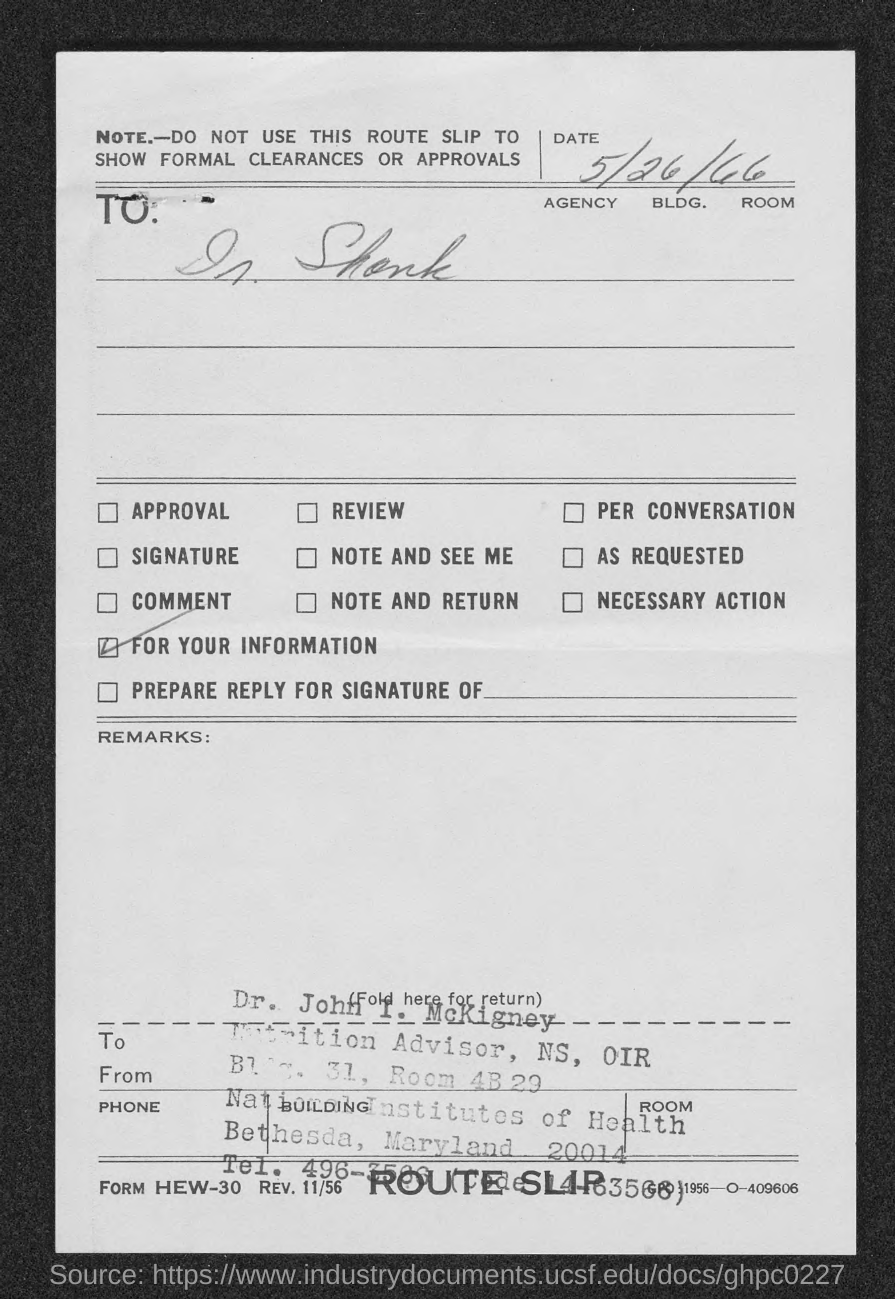Point out several critical features in this image. I request that the date mentioned in this document, which is 5/26/66, be formally acknowledged. Dr. John I. McKigney's designation is Nutrition Advisor, NS, OIR. 